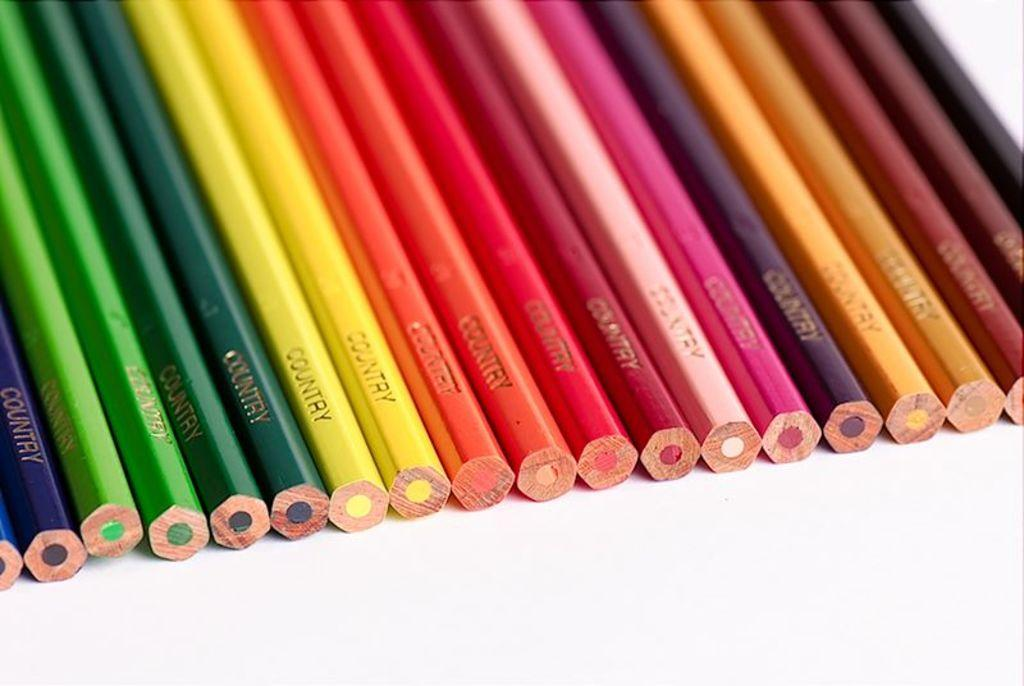<image>
Offer a succinct explanation of the picture presented. A series of unsharpened colored pencils made by the Country company lined up in a row. 